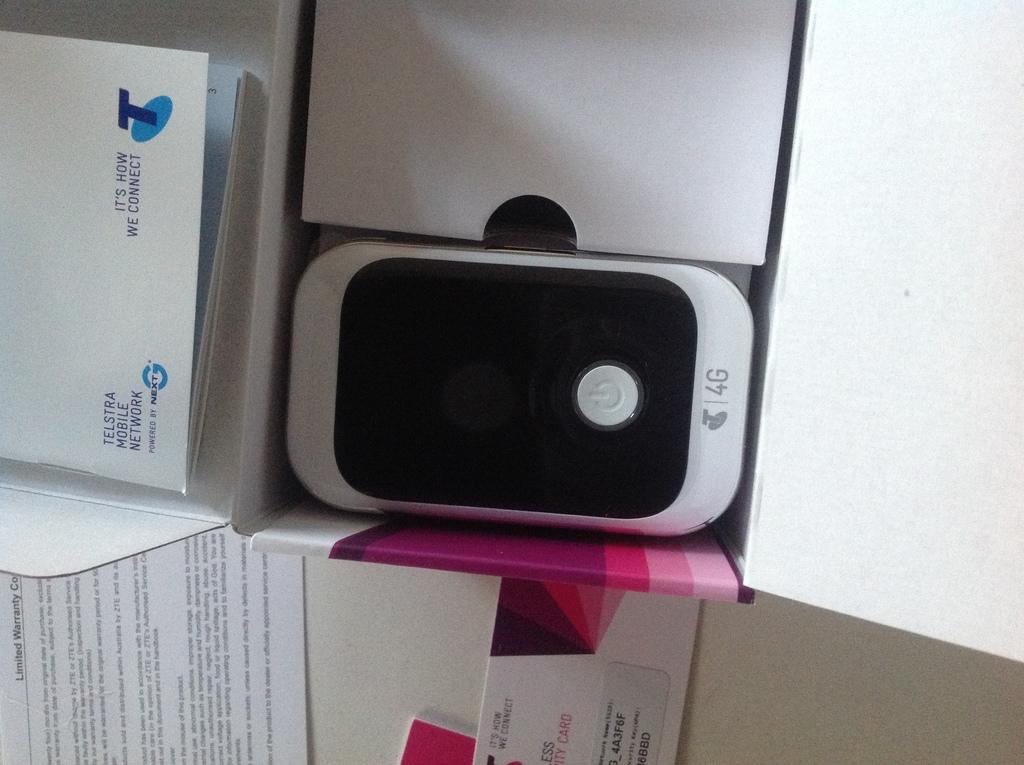<image>
Render a clear and concise summary of the photo. A Telstra Mobile Network 4G cellphone sits among white boxes. 